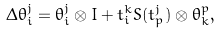<formula> <loc_0><loc_0><loc_500><loc_500>\Delta \theta _ { i } ^ { j } = \theta _ { i } ^ { j } \otimes I + t _ { i } ^ { k } S ( t _ { p } ^ { j } ) \otimes \theta _ { k } ^ { p } ,</formula> 